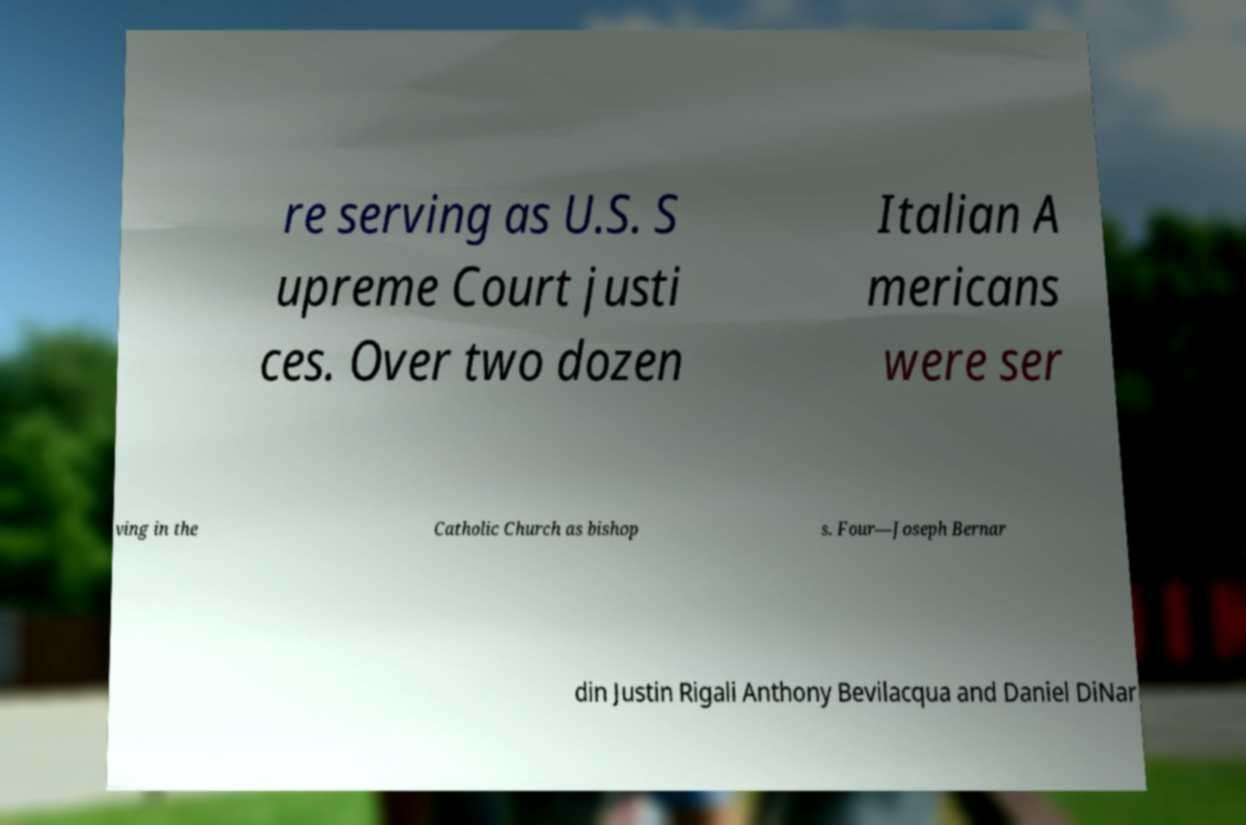Can you read and provide the text displayed in the image?This photo seems to have some interesting text. Can you extract and type it out for me? re serving as U.S. S upreme Court justi ces. Over two dozen Italian A mericans were ser ving in the Catholic Church as bishop s. Four—Joseph Bernar din Justin Rigali Anthony Bevilacqua and Daniel DiNar 